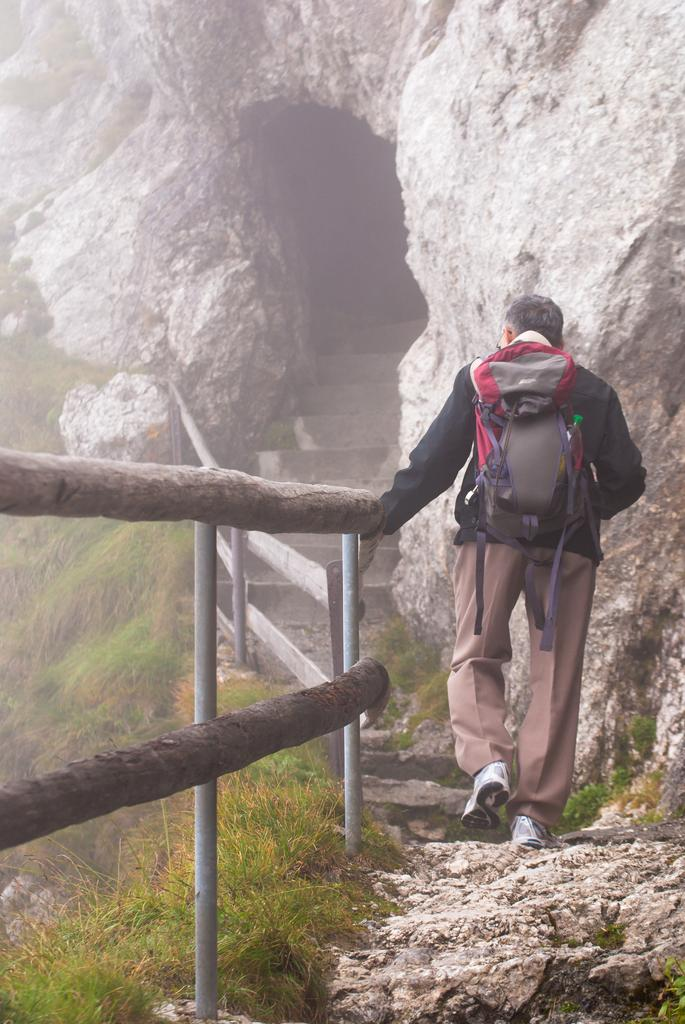What is the main subject of the image? There is a person in the image. What is the person wearing that is visible in the image? The person is wearing a bag. What type of barrier can be seen in the image? There is a fence in the image. What type of vegetation is present in the image? There is grass in the image. What type of natural formation is depicted in the image? The image depicts a cave. How many quarters can be seen in the image? There are no quarters present in the image. What type of zipper is visible on the person's bag in the image? There is no zipper visible on the person's bag in the image. 